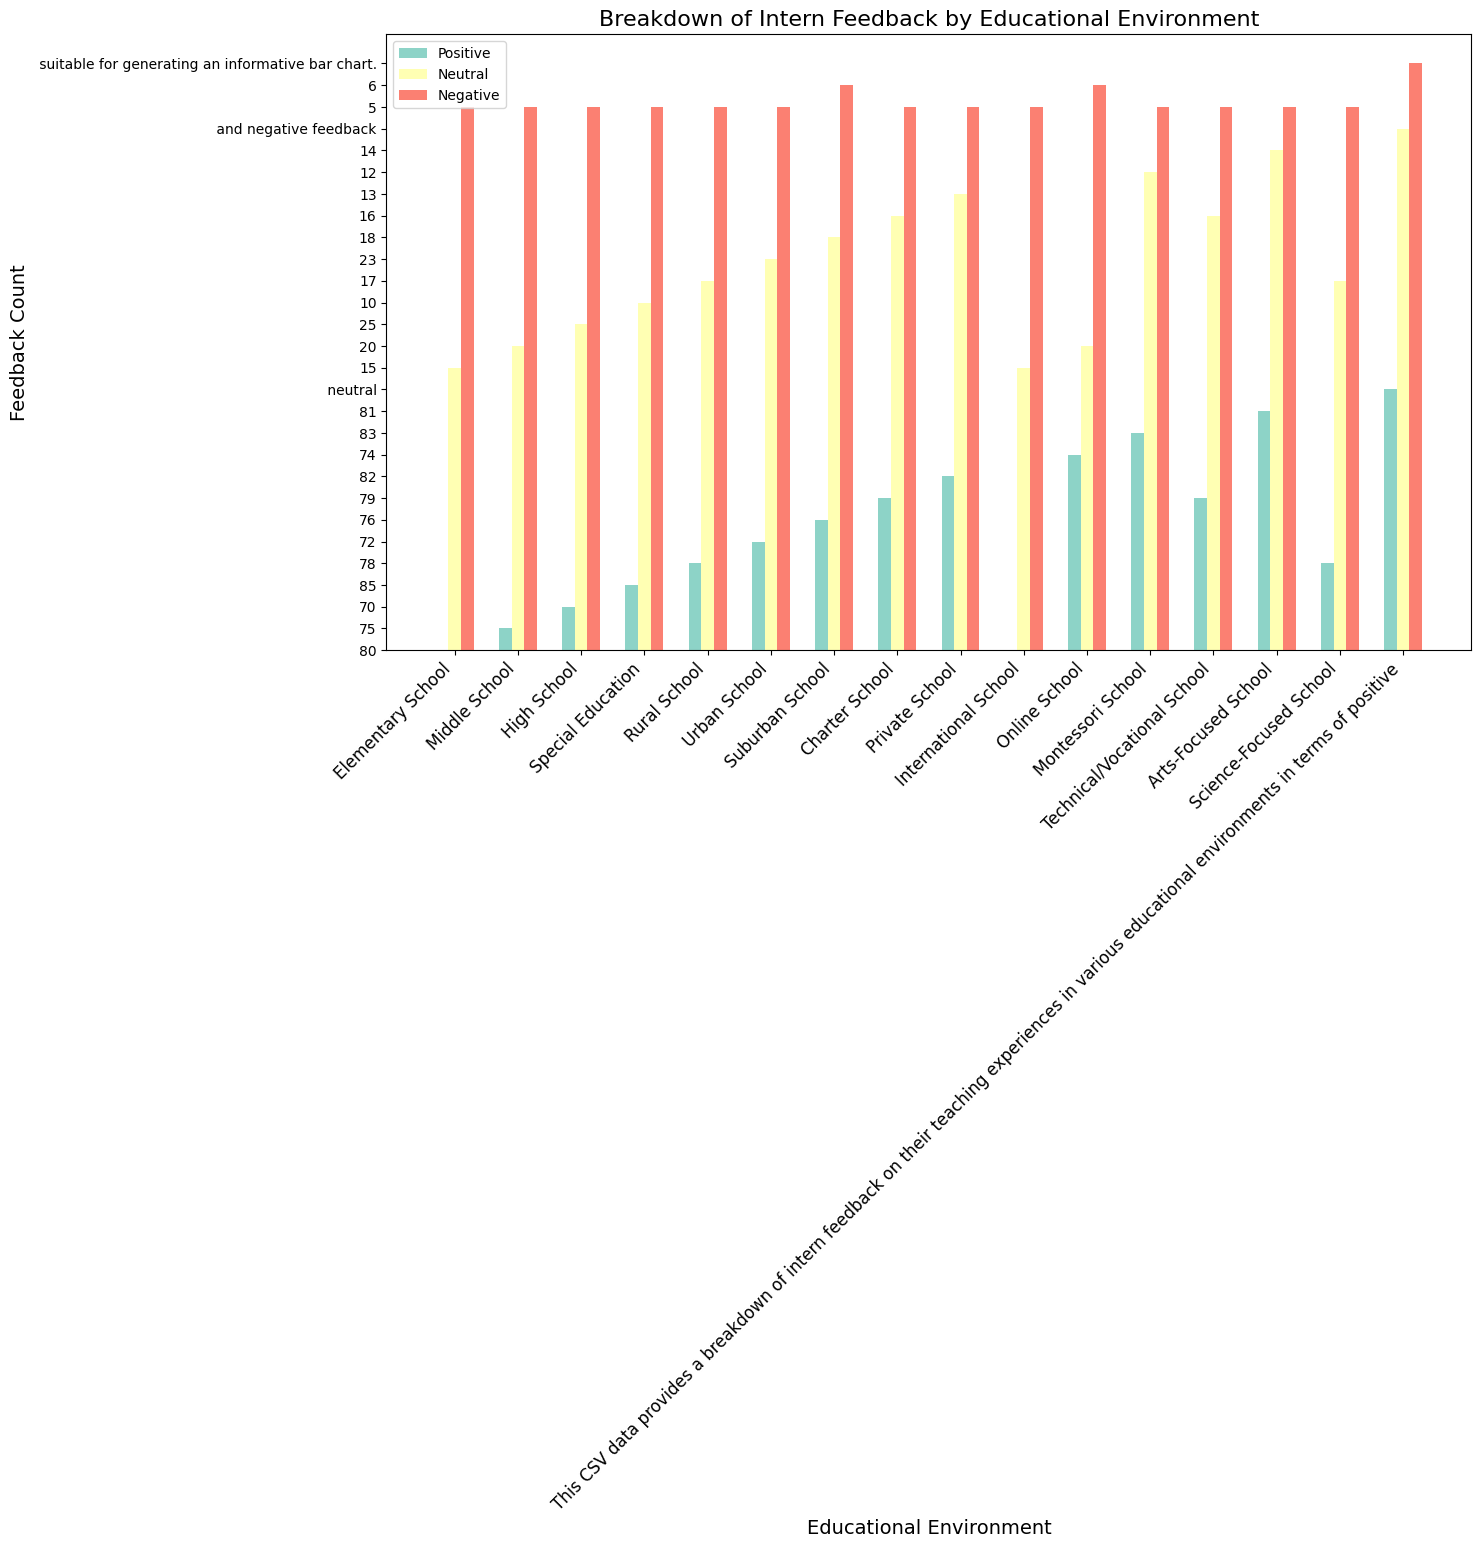Which educational environment received the most positive feedback? By observing the heights of the bars labeled as "Positive," the highest bar can be seen under "Special Education." Therefore, Special Education received the most positive feedback.
Answer: Special Education Which environment has the fewest negative feedbacks? All environments have the same small number of negative feedbacks, which can be verified by noting that the bars for negative feedbacks have the same height across all categories.
Answer: All environments What is the total feedback count for Online School? Sum the positive, neutral, and negative feedback counts for Online School: 74 (positive) + 20 (neutral) + 6 (negative) = 100.
Answer: 100 Compare the positive feedback between Rural School and Urban School. Which one is higher? By comparing the heights of the bars labeled "Positive" for both Rural School and Urban School, it can be seen that the Rural School has a higher positive feedback count (78) compared to Urban School (72).
Answer: Rural School What is the average neutral feedback count across all schools? Sum all the neutral feedback counts: 15 + 20 + 25 + 10 + 17 + 23 + 18 + 16 + 13 + 15 + 20 + 12 + 16 + 14 + 17 = 251. There are 15 environments, so average = 251 / 15 = 16.73.
Answer: 16.73 Which two educational environments have the same positive feedback counts? Observing the heights of the bars labeled "Positive," Elementary School and International School both have a positive feedback count of 80.
Answer: Elementary School and International School By how much does the negative feedback of Suburban School differ from that of Arts-Focused School? The negative feedback for Suburban School is 6, and for Arts-Focused School is 5. The difference is 6 - 5 = 1.
Answer: 1 Which educational environment has the largest difference between positive and negative feedback counts? Calculate the difference for each environment and find the maximum: 
- Elementary: 80 - 5 = 75
- Middle: 75 - 5 = 70
- High: 70 - 5 = 65
- Special Education: 85 - 5 = 80
- Rural: 78 - 5 = 73
- Urban: 72 - 5 = 67
- Suburban: 76 - 6 = 70
- Charter: 79 - 5 = 74
- Private: 82 - 5 = 77
- International: 80 - 5 = 75
- Online: 74 - 6 = 68
- Montessori: 83 - 5 = 78
- Technical/Vocational: 79 - 5 = 74
- Arts-Focused: 81 - 5 = 76
- Science-Focused: 78 - 5 = 73
The largest difference is 80 for Special Education.
Answer: Special Education 